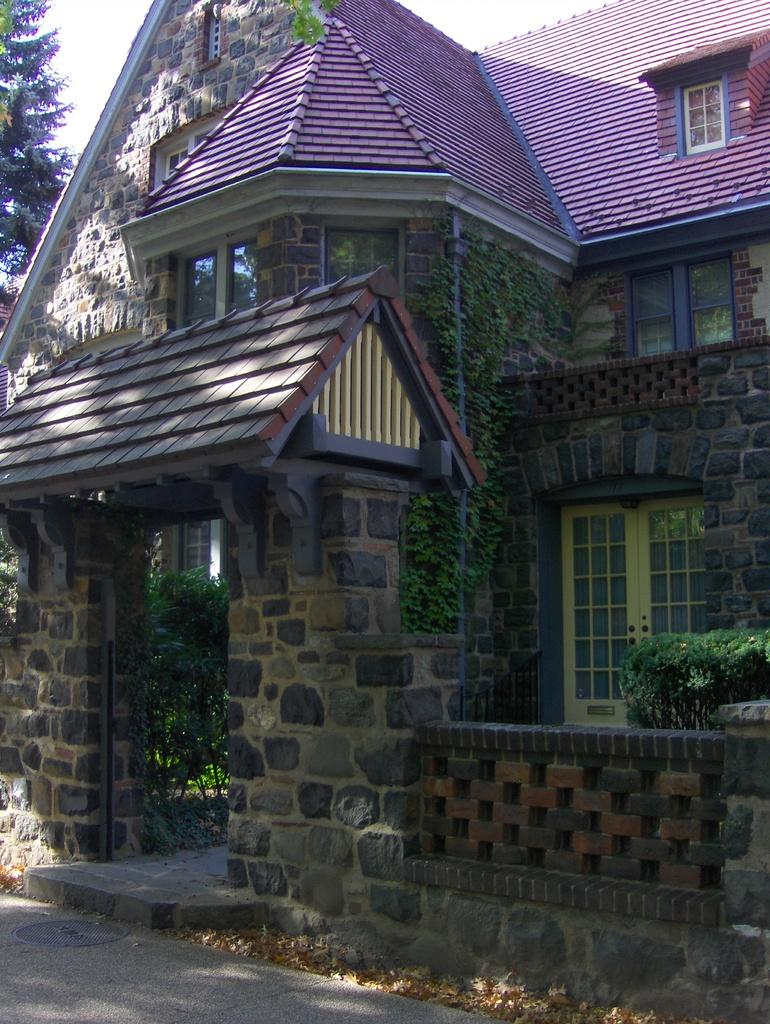What type of structure is visible in the image? There is a building in the image. What other elements can be seen in the image besides the building? There are plants and trees in the image. Can you describe the vegetation present in the image? The image contains both plants and trees. How many cubs are playing with the goose in the image? There are no cubs or geese present in the image. 